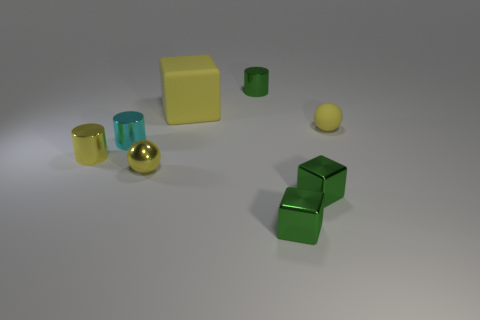Add 1 yellow shiny spheres. How many objects exist? 9 Subtract all spheres. How many objects are left? 6 Subtract 0 red blocks. How many objects are left? 8 Subtract all small yellow shiny spheres. Subtract all tiny blue cubes. How many objects are left? 7 Add 6 cyan metallic cylinders. How many cyan metallic cylinders are left? 7 Add 3 green shiny cylinders. How many green shiny cylinders exist? 4 